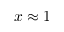Convert formula to latex. <formula><loc_0><loc_0><loc_500><loc_500>x \approx 1</formula> 